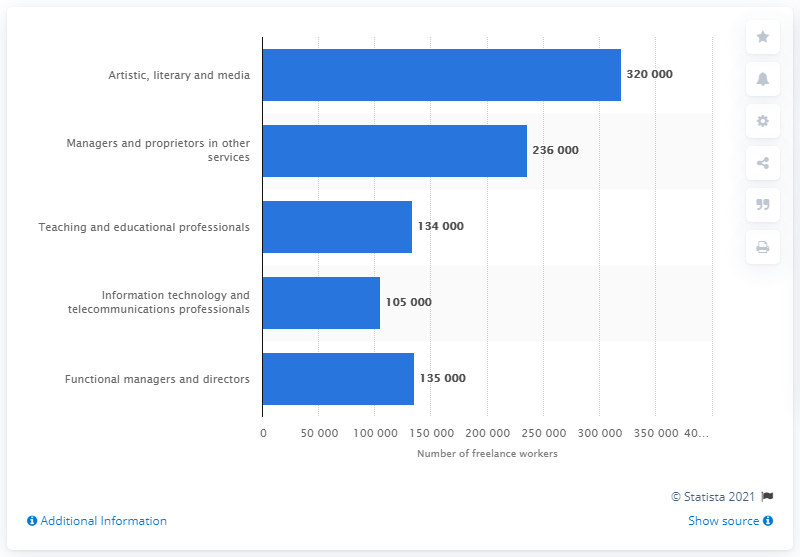Outline some significant characteristics in this image. In 2017, there were approximately 320,000 freelancers working in the artistic, literary, and media sector. 